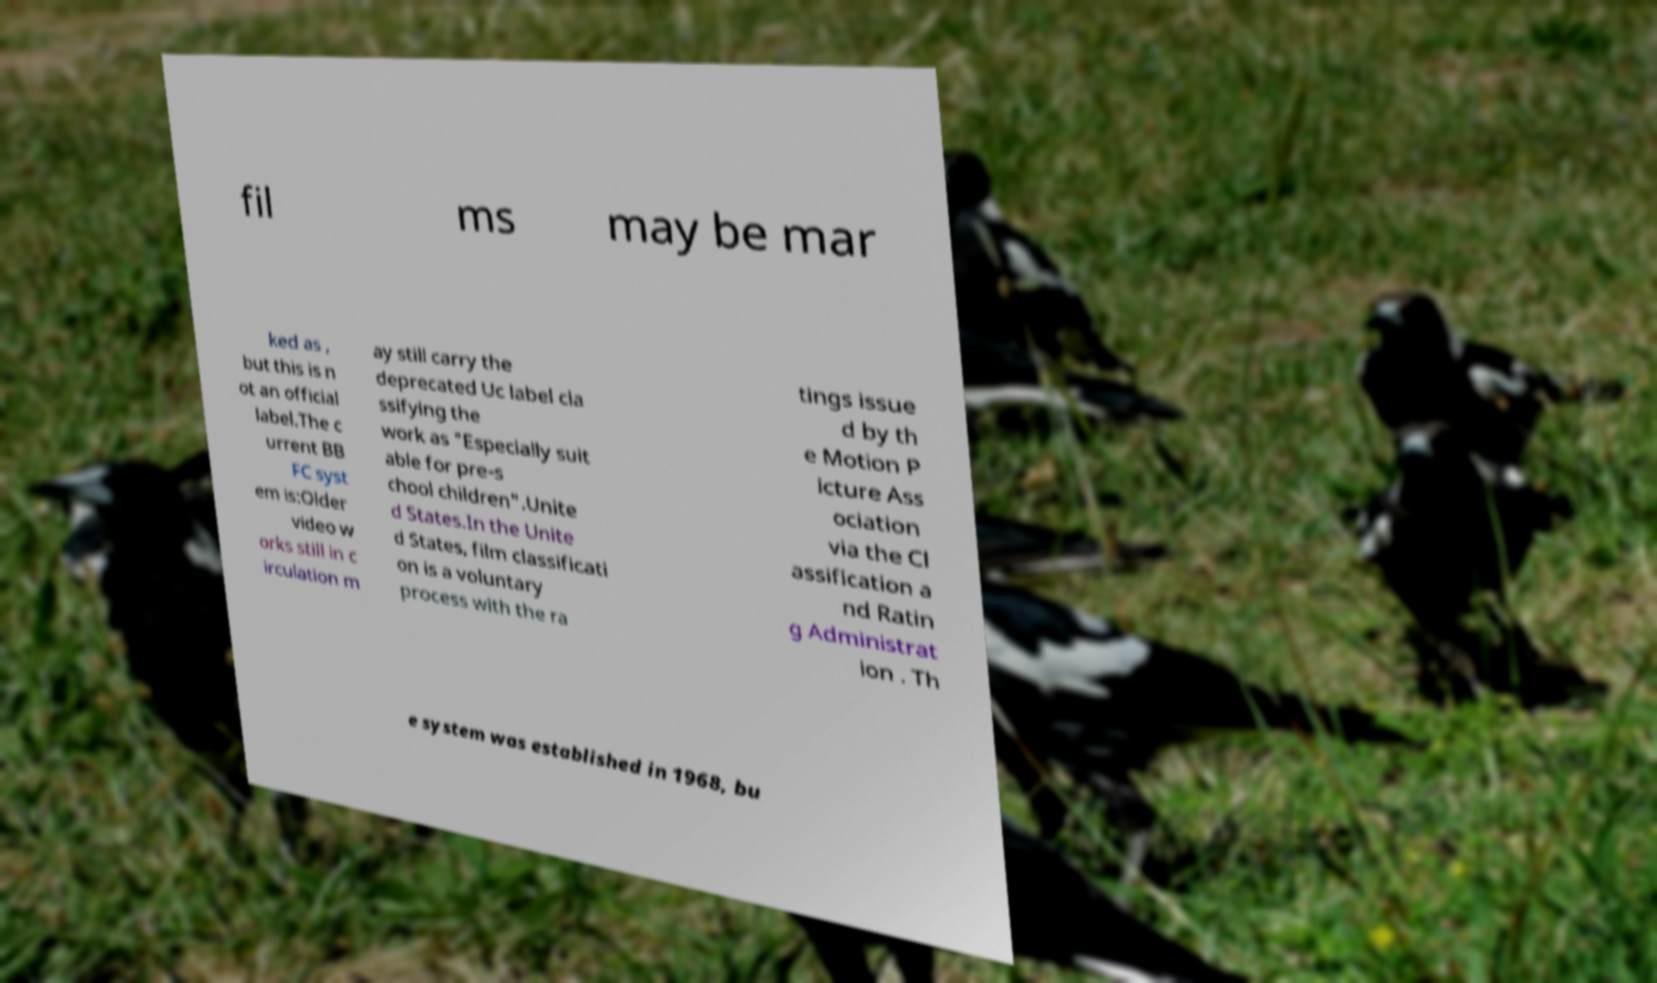What messages or text are displayed in this image? I need them in a readable, typed format. fil ms may be mar ked as , but this is n ot an official label.The c urrent BB FC syst em is:Older video w orks still in c irculation m ay still carry the deprecated Uc label cla ssifying the work as "Especially suit able for pre-s chool children".Unite d States.In the Unite d States, film classificati on is a voluntary process with the ra tings issue d by th e Motion P icture Ass ociation via the Cl assification a nd Ratin g Administrat ion . Th e system was established in 1968, bu 